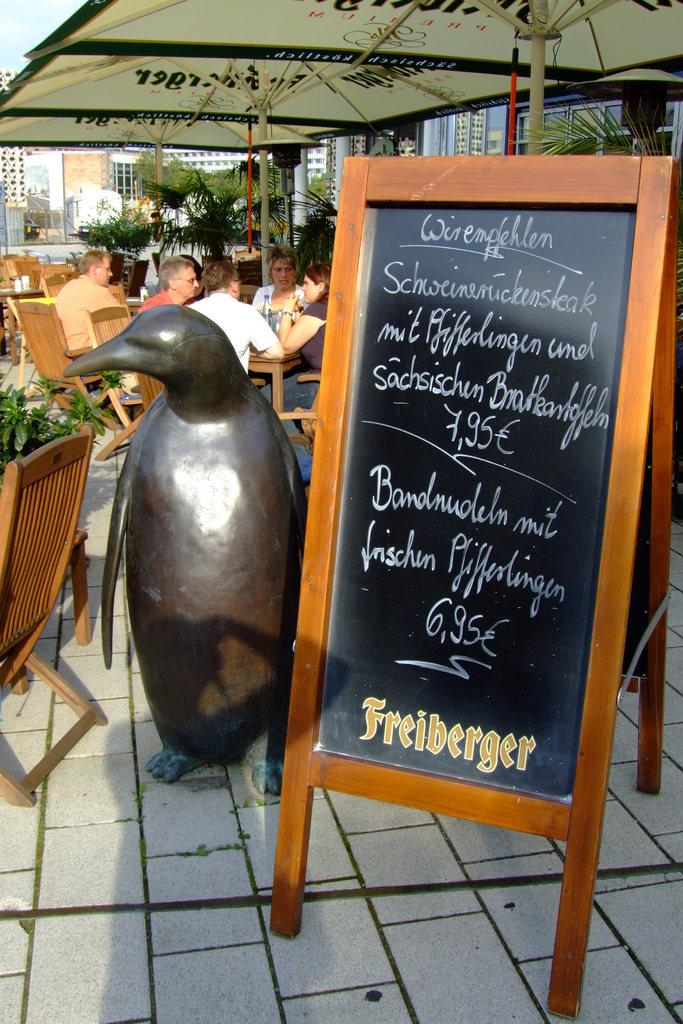What is the main object in the image? There is a board in the image. What animal can be seen in the image? There is a dolphin in the image. What type of furniture is present in the image? There is a chair in the image. What type of vegetation is in the image? There is a plant in the image. What can be seen in the background of the image? There are people sitting on chairs and a building in the background. What is visible at the top of the image? There is a tent visible at the top of the image. What is visible in the sky in the image? The sky is visible in the background of the image. What type of pen is being used to write on the board in the image? There is no pen visible in the image, and no writing is taking place on the board. 